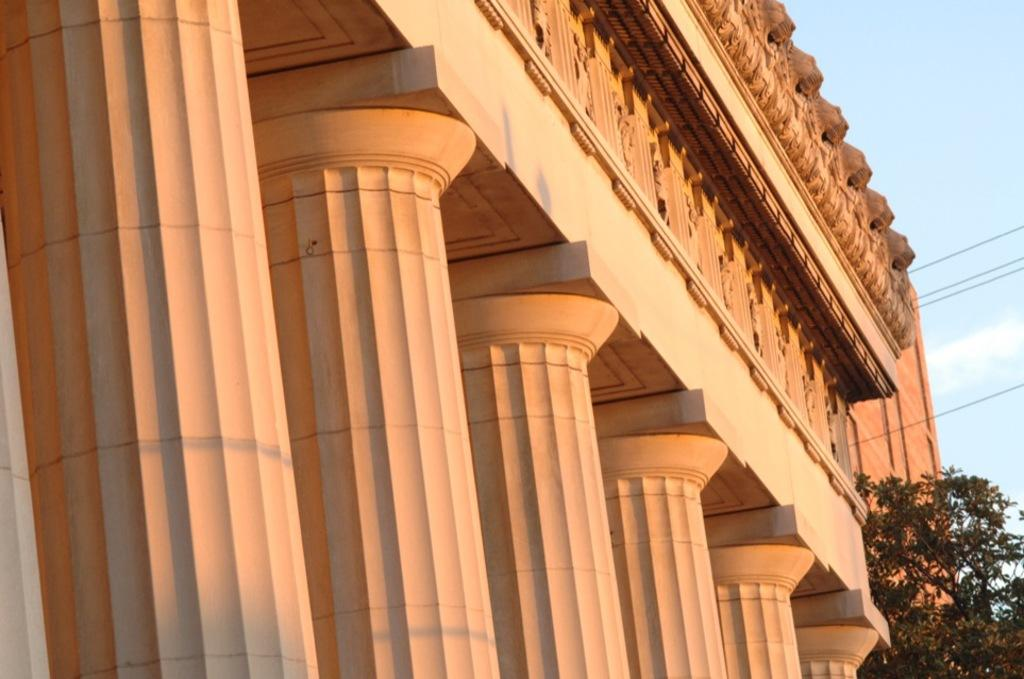What type of structure is visible in the image? There is a building in the image. What architectural features can be seen on the building? There are pillars visible on the building. Are there any additional elements present in the image? Yes, there are cables in the image. What can be seen on the right side of the building? There is a tree on the right side of the building. What is visible behind the building? The sky is visible behind the building. What type of music is being played by the mom in the image? There is no mom or music present in the image. 